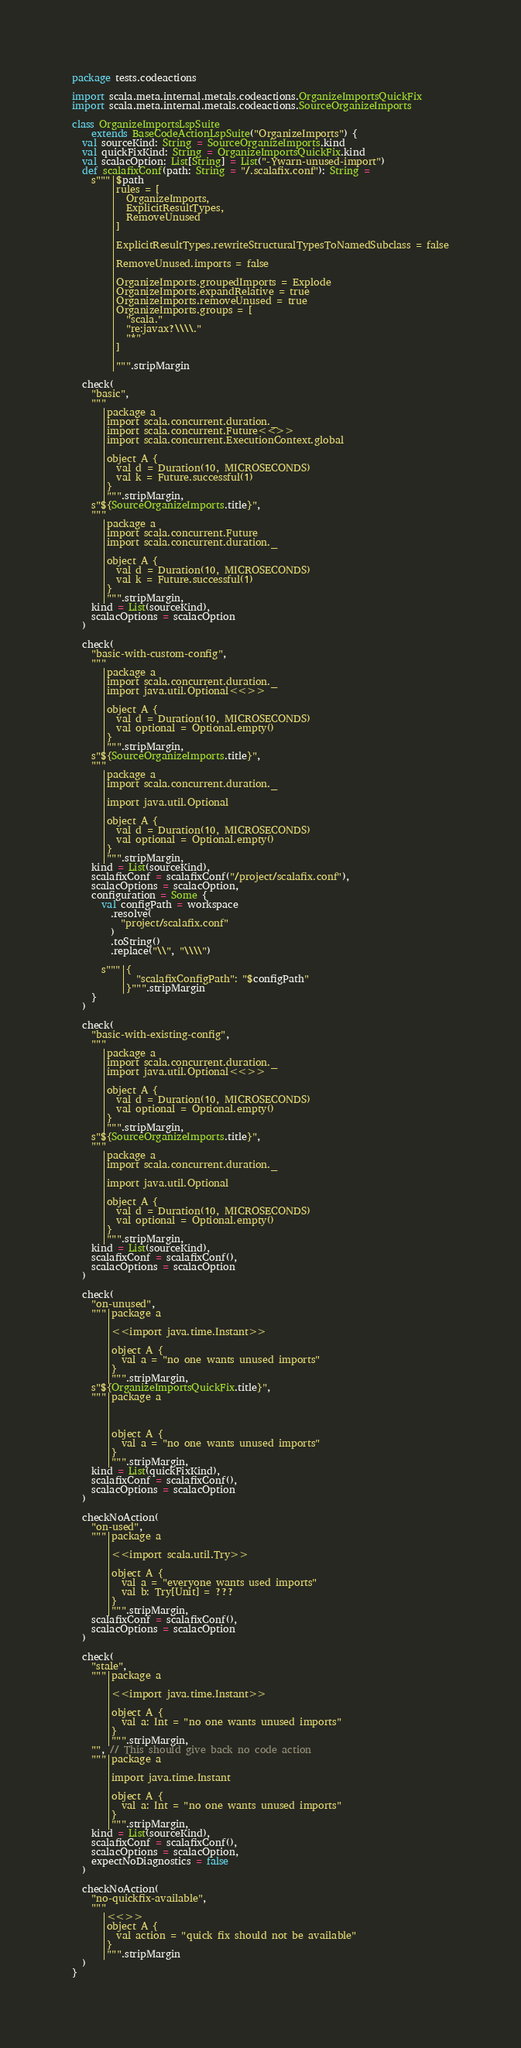Convert code to text. <code><loc_0><loc_0><loc_500><loc_500><_Scala_>package tests.codeactions

import scala.meta.internal.metals.codeactions.OrganizeImportsQuickFix
import scala.meta.internal.metals.codeactions.SourceOrganizeImports

class OrganizeImportsLspSuite
    extends BaseCodeActionLspSuite("OrganizeImports") {
  val sourceKind: String = SourceOrganizeImports.kind
  val quickFixKind: String = OrganizeImportsQuickFix.kind
  val scalacOption: List[String] = List("-Ywarn-unused-import")
  def scalafixConf(path: String = "/.scalafix.conf"): String =
    s"""|$path
        |rules = [
        |  OrganizeImports,
        |  ExplicitResultTypes,
        |  RemoveUnused
        |]
        |
        |ExplicitResultTypes.rewriteStructuralTypesToNamedSubclass = false
        |
        |RemoveUnused.imports = false
        |
        |OrganizeImports.groupedImports = Explode
        |OrganizeImports.expandRelative = true
        |OrganizeImports.removeUnused = true
        |OrganizeImports.groups = [
        |  "scala."
        |  "re:javax?\\\\."
        |  "*"
        |]
        |
        |""".stripMargin

  check(
    "basic",
    """
      |package a
      |import scala.concurrent.duration._
      |import scala.concurrent.Future<<>>
      |import scala.concurrent.ExecutionContext.global
      |
      |object A {
      |  val d = Duration(10, MICROSECONDS)
      |  val k = Future.successful(1)
      |}
      |""".stripMargin,
    s"${SourceOrganizeImports.title}",
    """
      |package a
      |import scala.concurrent.Future
      |import scala.concurrent.duration._
      |
      |object A {
      |  val d = Duration(10, MICROSECONDS)
      |  val k = Future.successful(1)
      |}
      |""".stripMargin,
    kind = List(sourceKind),
    scalacOptions = scalacOption
  )

  check(
    "basic-with-custom-config",
    """
      |package a
      |import scala.concurrent.duration._
      |import java.util.Optional<<>>
      |
      |object A {
      |  val d = Duration(10, MICROSECONDS)
      |  val optional = Optional.empty()
      |}
      |""".stripMargin,
    s"${SourceOrganizeImports.title}",
    """
      |package a
      |import scala.concurrent.duration._
      |
      |import java.util.Optional
      |
      |object A {
      |  val d = Duration(10, MICROSECONDS)
      |  val optional = Optional.empty()
      |}
      |""".stripMargin,
    kind = List(sourceKind),
    scalafixConf = scalafixConf("/project/scalafix.conf"),
    scalacOptions = scalacOption,
    configuration = Some {
      val configPath = workspace
        .resolve(
          "project/scalafix.conf"
        )
        .toString()
        .replace("\\", "\\\\")

      s"""|{
          |  "scalafixConfigPath": "$configPath"
          |}""".stripMargin
    }
  )

  check(
    "basic-with-existing-config",
    """
      |package a
      |import scala.concurrent.duration._
      |import java.util.Optional<<>>
      |
      |object A {
      |  val d = Duration(10, MICROSECONDS)
      |  val optional = Optional.empty()
      |}
      |""".stripMargin,
    s"${SourceOrganizeImports.title}",
    """
      |package a
      |import scala.concurrent.duration._
      |
      |import java.util.Optional
      |
      |object A {
      |  val d = Duration(10, MICROSECONDS)
      |  val optional = Optional.empty()
      |}
      |""".stripMargin,
    kind = List(sourceKind),
    scalafixConf = scalafixConf(),
    scalacOptions = scalacOption
  )

  check(
    "on-unused",
    """|package a
       |
       |<<import java.time.Instant>>
       |
       |object A {
       |  val a = "no one wants unused imports"
       |}
       |""".stripMargin,
    s"${OrganizeImportsQuickFix.title}",
    """|package a
       |
       |
       |
       |object A {
       |  val a = "no one wants unused imports"
       |}
       |""".stripMargin,
    kind = List(quickFixKind),
    scalafixConf = scalafixConf(),
    scalacOptions = scalacOption
  )

  checkNoAction(
    "on-used",
    """|package a
       |
       |<<import scala.util.Try>>
       |
       |object A {
       |  val a = "everyone wants used imports"
       |  val b: Try[Unit] = ???
       |}
       |""".stripMargin,
    scalafixConf = scalafixConf(),
    scalacOptions = scalacOption
  )

  check(
    "stale",
    """|package a
       |
       |<<import java.time.Instant>>
       |
       |object A {
       |  val a: Int = "no one wants unused imports"
       |}
       |""".stripMargin,
    "", // This should give back no code action
    """|package a
       |
       |import java.time.Instant
       |
       |object A {
       |  val a: Int = "no one wants unused imports"
       |}
       |""".stripMargin,
    kind = List(sourceKind),
    scalafixConf = scalafixConf(),
    scalacOptions = scalacOption,
    expectNoDiagnostics = false
  )

  checkNoAction(
    "no-quickfix-available",
    """
      |<<>>
      |object A {
      |  val action = "quick fix should not be available"
      |}
      |""".stripMargin
  )
}
</code> 